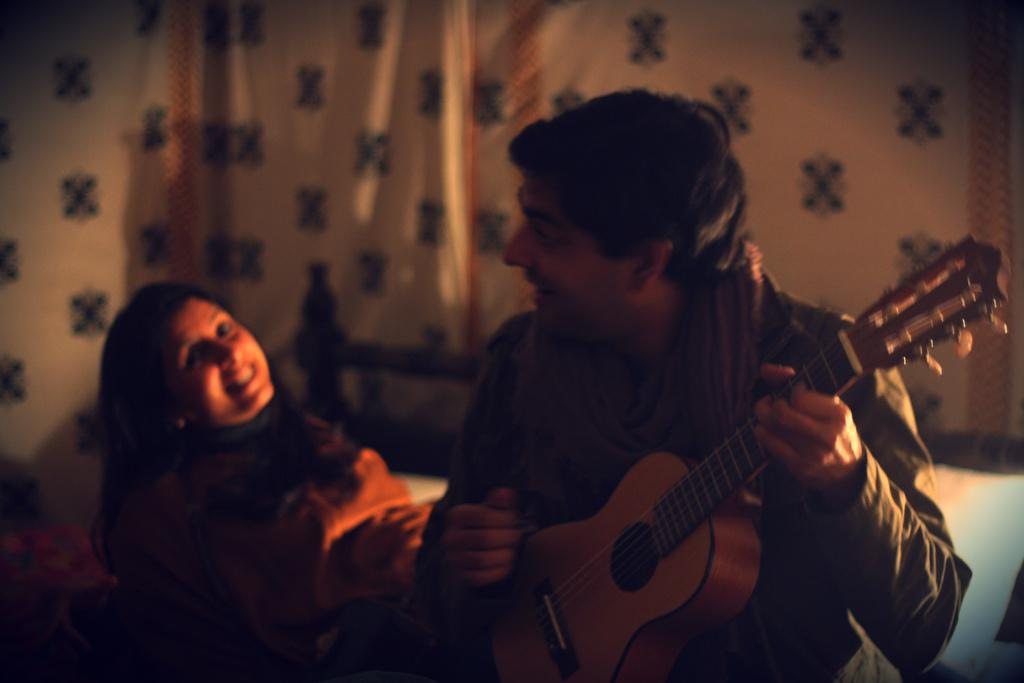What is the man in the image holding? The man is holding a guitar. Who else is present in the image? There is a woman in the image. What is the woman doing in the image? The woman is sitting. What type of tail can be seen on the woman in the image? There is no tail visible on the woman in the image. How many stomachs does the man have in the image? The number of stomachs cannot be determined from the image, as it only shows the man holding a guitar and does not provide any information about his internal anatomy. 